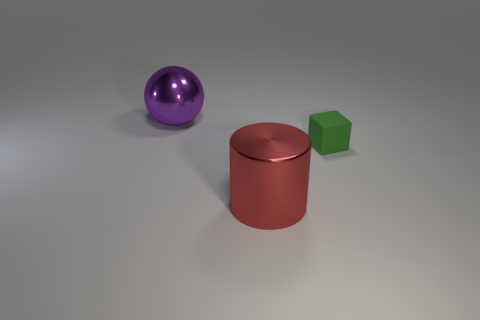Is the number of purple objects that are left of the large red shiny cylinder less than the number of spheres?
Give a very brief answer. No. Are any green rubber objects visible?
Offer a very short reply. Yes. Is the color of the object in front of the green thing the same as the rubber block?
Keep it short and to the point. No. Does the metallic cylinder have the same size as the green object?
Keep it short and to the point. No. The other thing that is the same material as the large red thing is what shape?
Your answer should be compact. Sphere. How many other things are there of the same shape as the large red shiny thing?
Ensure brevity in your answer.  0. The metal object that is on the right side of the large object behind the large metallic object in front of the block is what shape?
Your answer should be compact. Cylinder. How many cylinders are green matte objects or large purple things?
Make the answer very short. 0. There is a shiny thing that is in front of the green block; is there a object that is behind it?
Keep it short and to the point. Yes. Are there any other things that are the same material as the block?
Provide a succinct answer. No. 